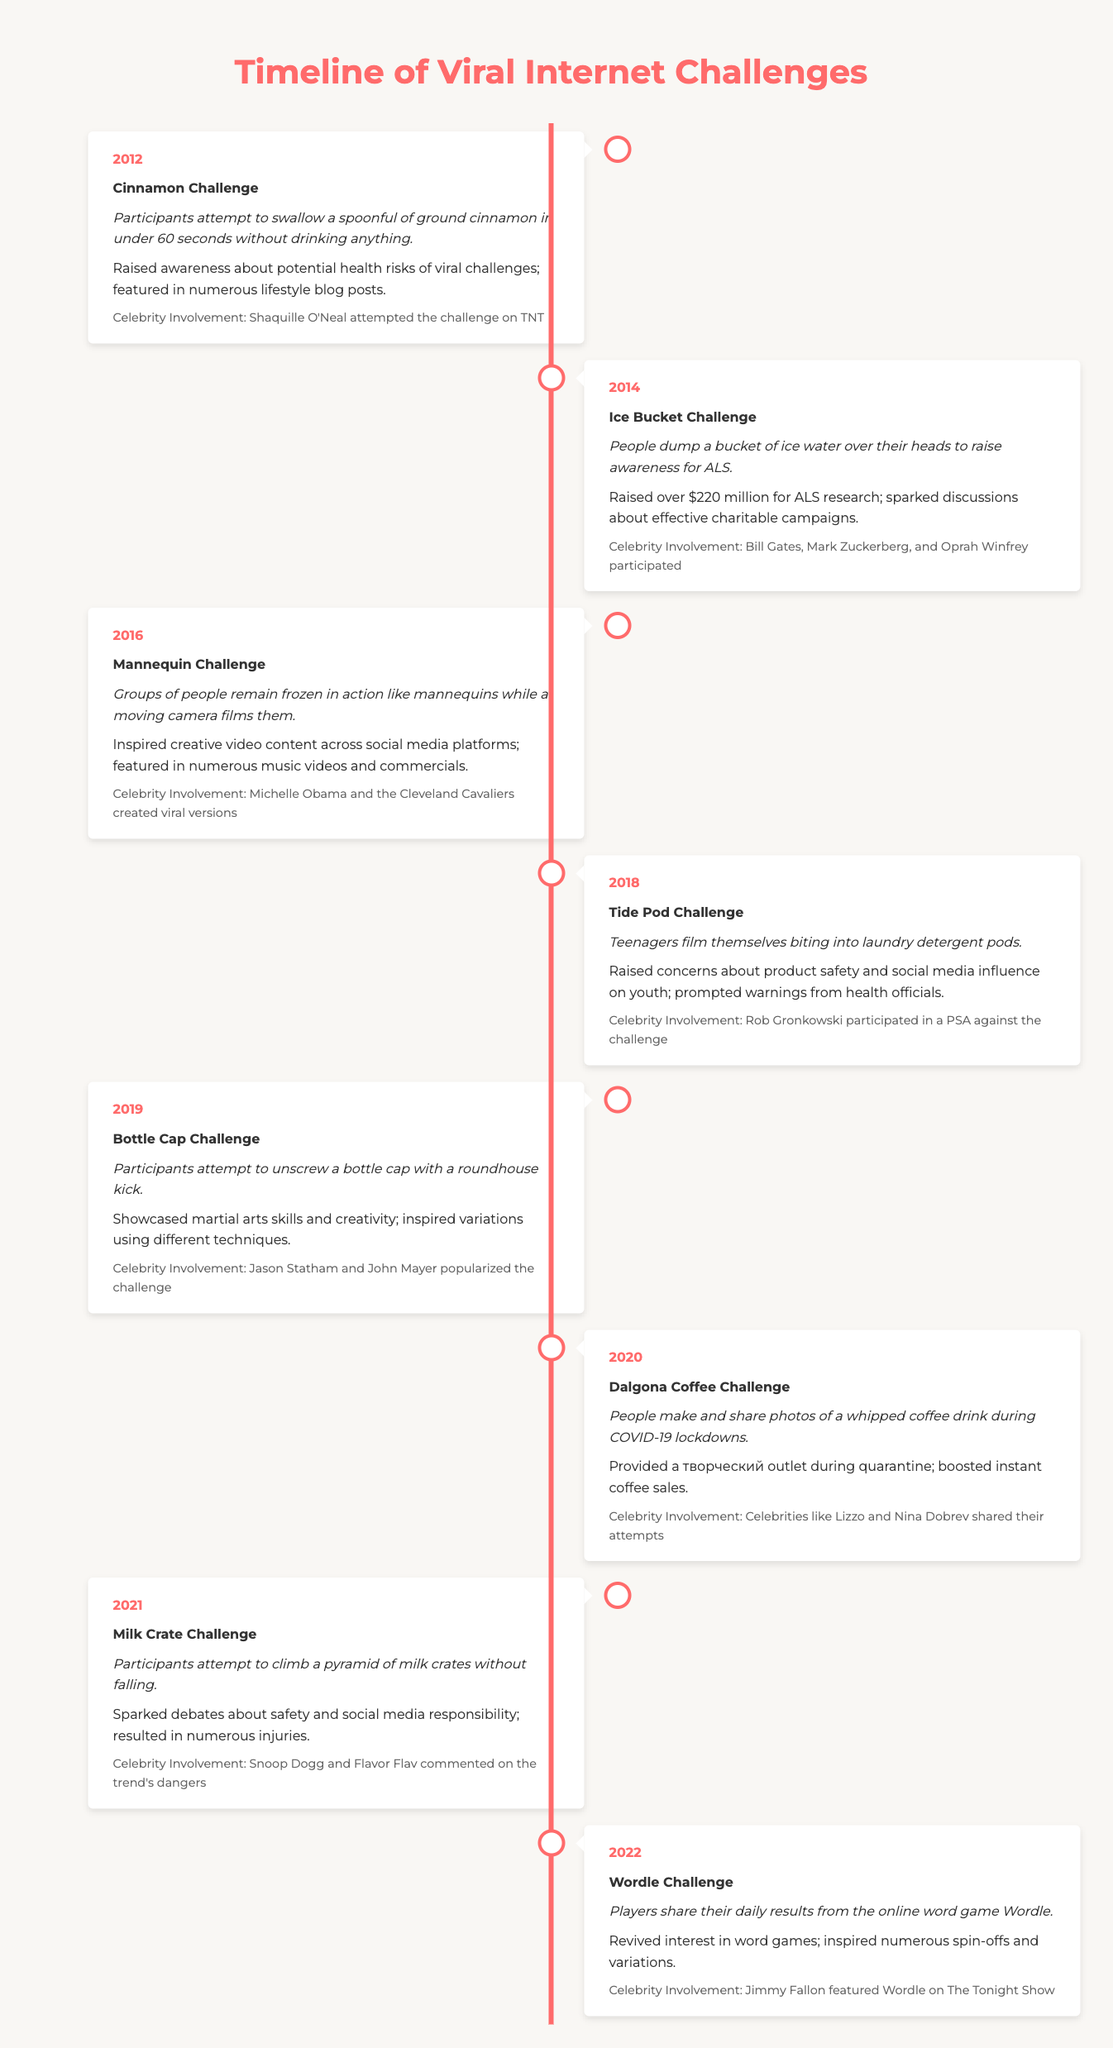What year did the Ice Bucket Challenge take place? The Ice Bucket Challenge is listed under the year 2014 in the table.
Answer: 2014 Which challenge raised over $220 million for ALS research? The impact section shows that the Ice Bucket Challenge raised over $220 million for ALS research.
Answer: Ice Bucket Challenge How many challenges involved celebrity participation? From the timeline, all challenges mention celebrity involvement, totaling 8 challenges.
Answer: 8 What was the main goal of the Dalgona Coffee Challenge? The description states that participants made and shared photos of a whipped coffee drink during COVID-19 lockdowns, suggesting it was a creative outlet during that time.
Answer: To provide a creative outlet Which challenge had a negative impact concerning health risks? The Tide Pod Challenge is noted to have raised concerns about product safety and social media influence on youth, indicating its negative impact.
Answer: Tide Pod Challenge Which two challenges occurred in even-numbered years and had significant celebrity involvement? The Ice Bucket Challenge (2014) and the Milk Crate Challenge (2021) both experienced notable celebrity participation, as outlined in the timeline.
Answer: Ice Bucket Challenge and Milk Crate Challenge What is the average year for the challenges listed? The years of the challenges are 2012, 2014, 2016, 2018, 2019, 2020, 2021, 2022; summing these gives 2012 + 2014 + 2016 + 2018 + 2019 + 2020 + 2021 + 2022 = 1612; dividing by 8 (the number of challenges) gives an average year of 2012.
Answer: 2018.5 Did any of the challenges focus on promoting health or safety awareness? Yes, the Ice Bucket Challenge raised awareness for ALS, and the Tide Pod Challenge prompted warnings from health officials, confirming that both challenges promote health awareness.
Answer: Yes How many years apart are the Cinnamon Challenge and the Wordle Challenge? The Cinnamon Challenge occurred in 2012 and the Wordle Challenge in 2022, making them 10 years apart.
Answer: 10 years 